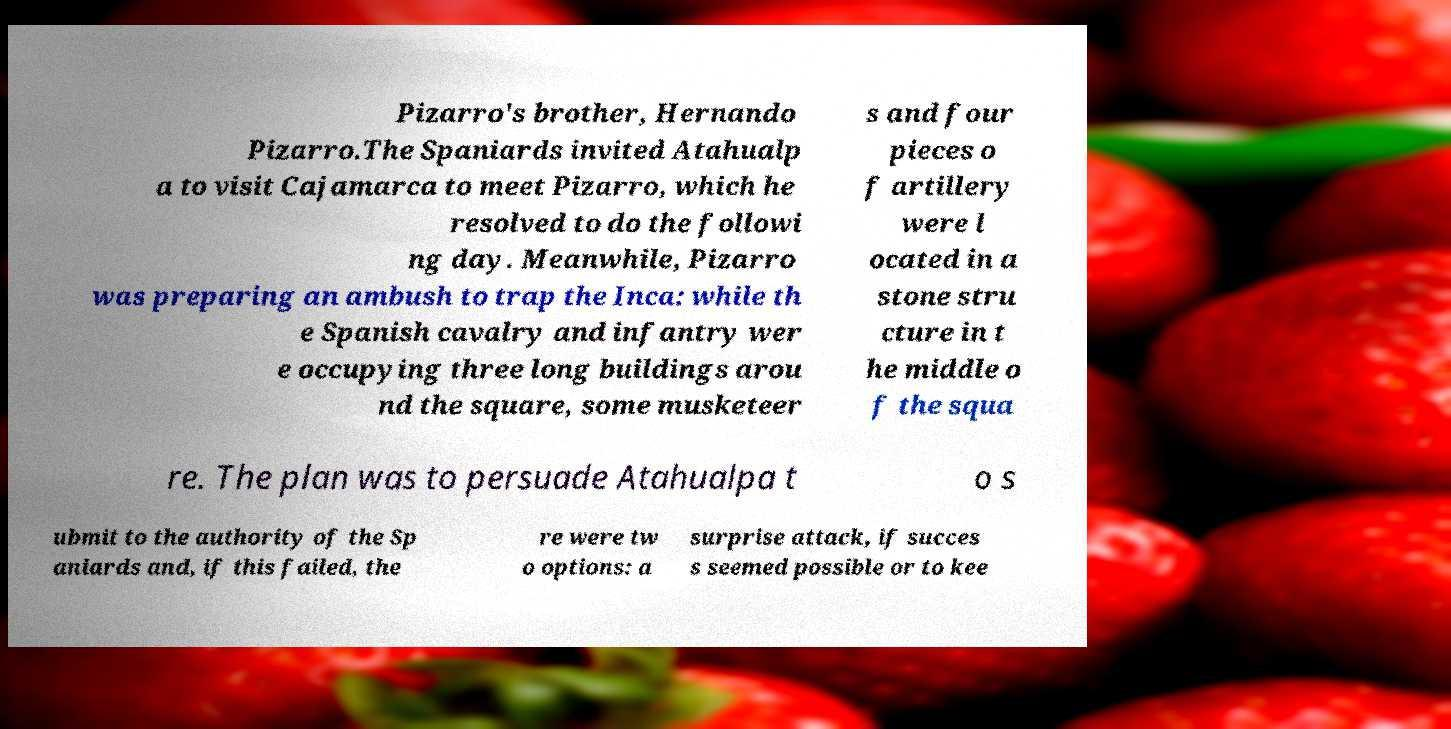Please identify and transcribe the text found in this image. Pizarro's brother, Hernando Pizarro.The Spaniards invited Atahualp a to visit Cajamarca to meet Pizarro, which he resolved to do the followi ng day. Meanwhile, Pizarro was preparing an ambush to trap the Inca: while th e Spanish cavalry and infantry wer e occupying three long buildings arou nd the square, some musketeer s and four pieces o f artillery were l ocated in a stone stru cture in t he middle o f the squa re. The plan was to persuade Atahualpa t o s ubmit to the authority of the Sp aniards and, if this failed, the re were tw o options: a surprise attack, if succes s seemed possible or to kee 